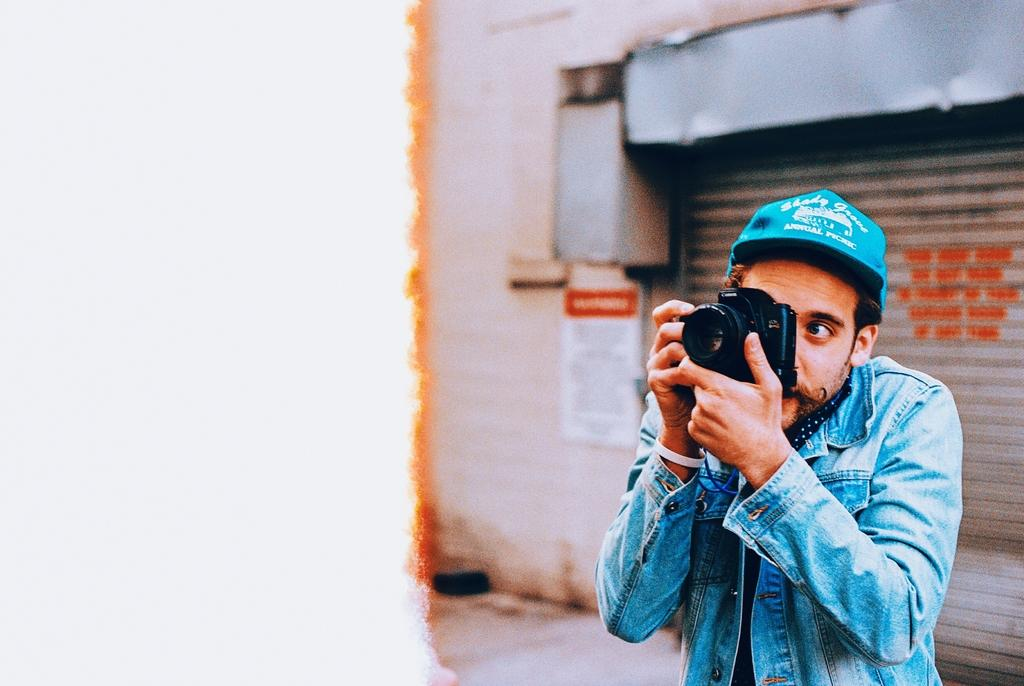Who is present in the image? There is a man in the image. Where is the man located in the image? The man is on the right side of the image. What is the man doing in the image? The man is taking a photograph with his camera. What type of cloth is the man using to take the photograph in the image? There is no cloth present in the image; the man is using a camera to take the photograph. 